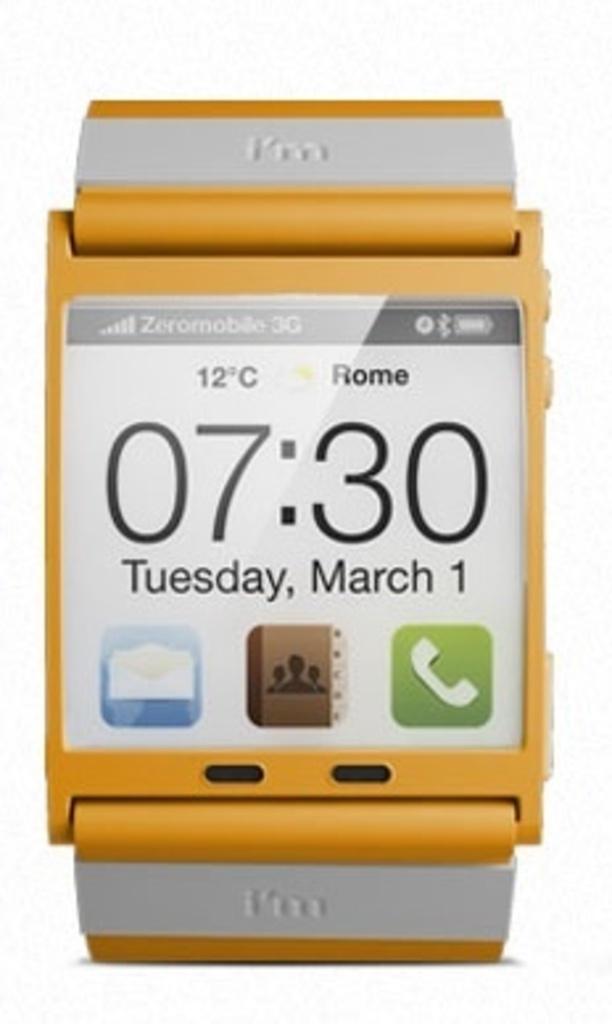What language is this ad in?
Your answer should be very brief. English. What is the date shown?
Offer a terse response. March 1. 